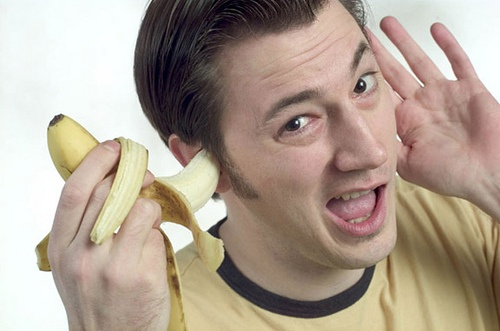Describe the objects in this image and their specific colors. I can see people in white, tan, darkgray, and gray tones and banana in white, khaki, tan, beige, and olive tones in this image. 